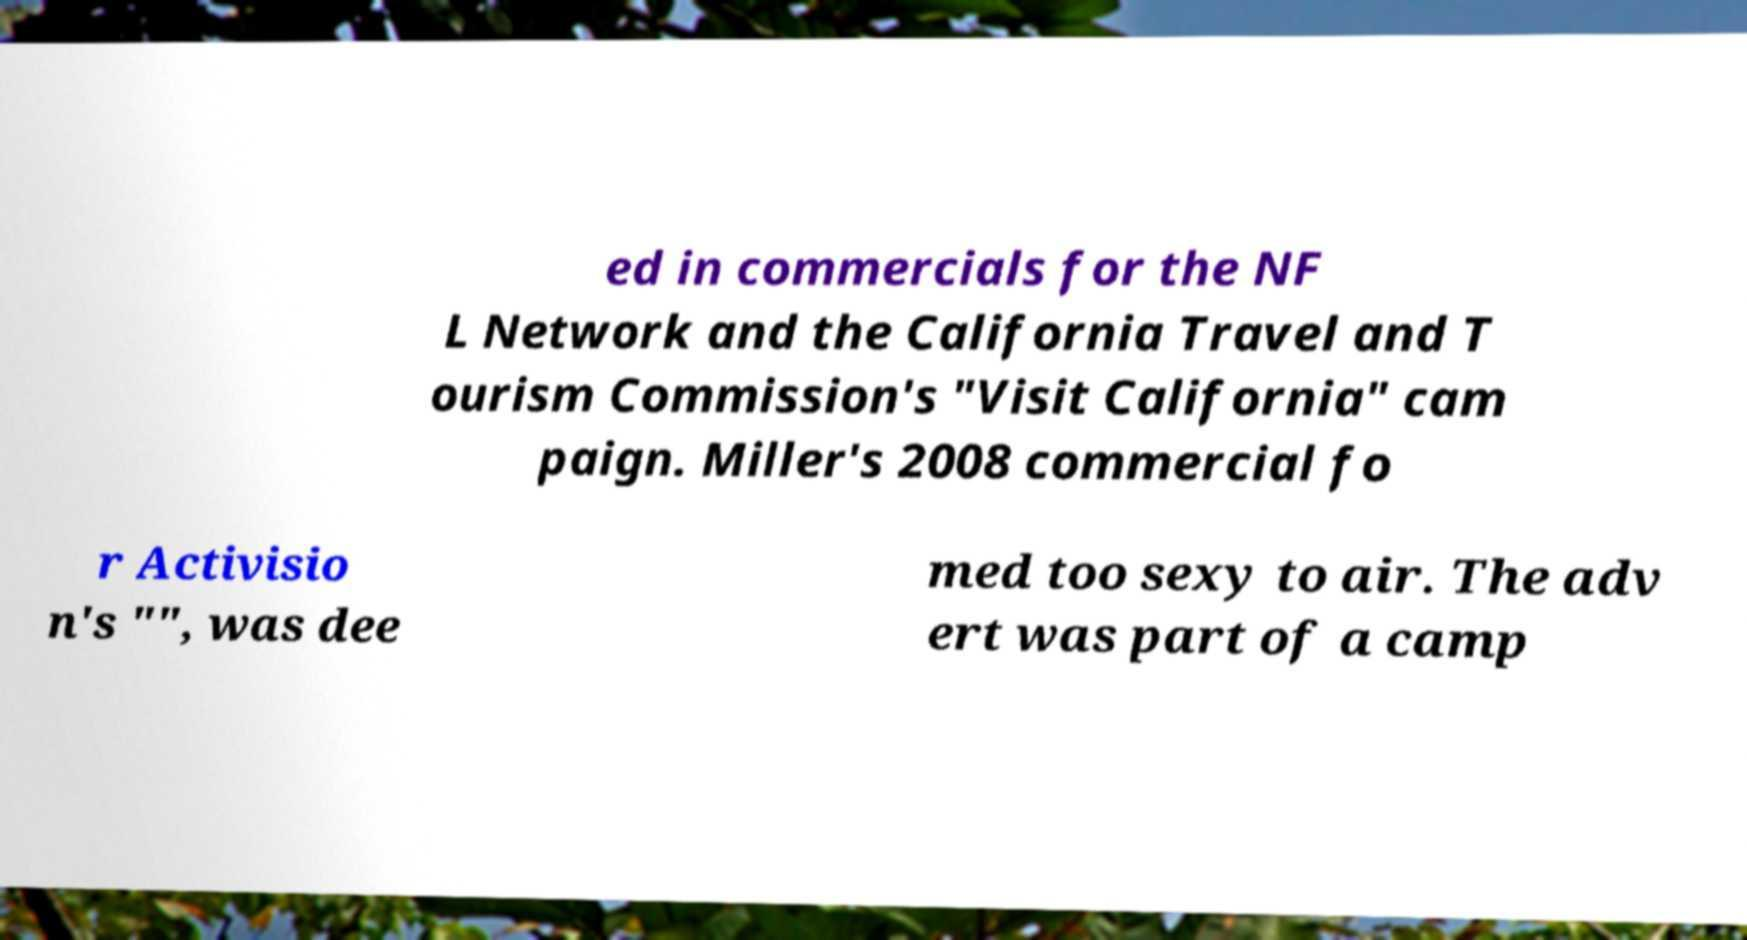There's text embedded in this image that I need extracted. Can you transcribe it verbatim? ed in commercials for the NF L Network and the California Travel and T ourism Commission's "Visit California" cam paign. Miller's 2008 commercial fo r Activisio n's "", was dee med too sexy to air. The adv ert was part of a camp 